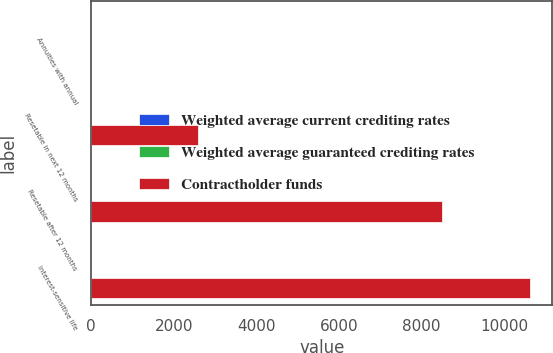<chart> <loc_0><loc_0><loc_500><loc_500><stacked_bar_chart><ecel><fcel>Annuities with annual<fcel>Resetable in next 12 months<fcel>Resetable after 12 months<fcel>Interest-sensitive life<nl><fcel>Weighted average current crediting rates<fcel>3.06<fcel>1.62<fcel>1.76<fcel>3.99<nl><fcel>Weighted average guaranteed crediting rates<fcel>3.08<fcel>4.37<fcel>3.98<fcel>4.46<nl><fcel>Contractholder funds<fcel>3.99<fcel>2597<fcel>8503<fcel>10637<nl></chart> 